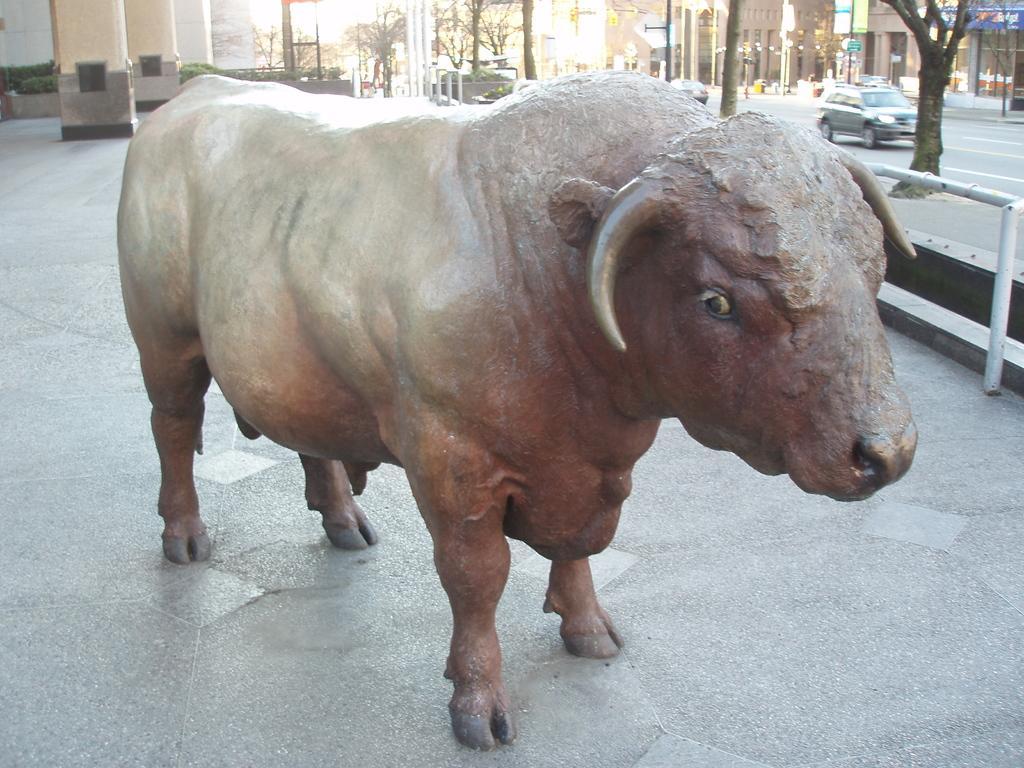Can you describe this image briefly? This picture is clicked outside. In the center we can see the sculpture of an animal. In the background we can see the pillars, green leaves, trees, lights, vehicles, buildings, metal roads and many other objects. 